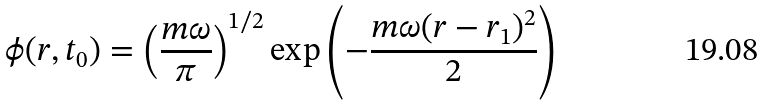<formula> <loc_0><loc_0><loc_500><loc_500>\phi ( r , t _ { 0 } ) = \left ( \frac { m \omega } { \pi } \right ) ^ { 1 / 2 } \exp { \left ( - \frac { m \omega ( r - r _ { 1 } ) ^ { 2 } } { 2 } \right ) }</formula> 